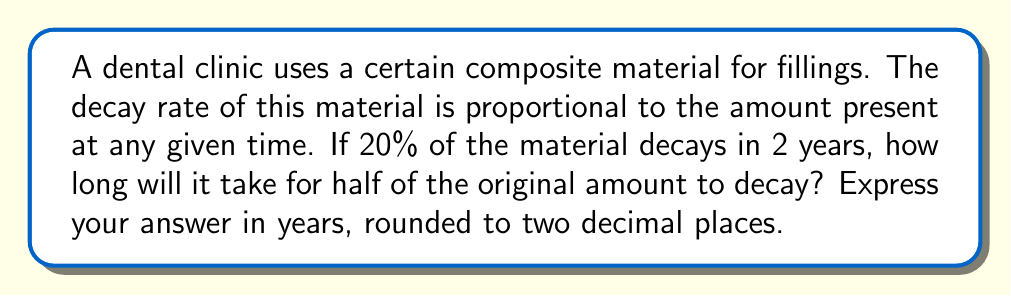Solve this math problem. Let's approach this step-by-step using differential equations:

1) Let $A(t)$ be the amount of material present at time $t$ (in years).

2) The decay rate is proportional to the amount present, so we can write:

   $$\frac{dA}{dt} = -kA$$

   where $k$ is the decay constant.

3) The solution to this differential equation is:

   $$A(t) = A_0e^{-kt}$$

   where $A_0$ is the initial amount.

4) We're told that 20% decays in 2 years. This means that after 2 years, 80% remains:

   $$\frac{A(2)}{A_0} = 0.8 = e^{-2k}$$

5) Taking the natural log of both sides:

   $$\ln(0.8) = -2k$$

6) Solving for $k$:

   $$k = -\frac{\ln(0.8)}{2} \approx 0.1115$$

7) Now, we want to find $t$ when half the original amount remains:

   $$\frac{A(t)}{A_0} = 0.5 = e^{-kt}$$

8) Taking the natural log again:

   $$\ln(0.5) = -kt$$

9) Solving for $t$:

   $$t = -\frac{\ln(0.5)}{k} = \frac{\ln(2)}{0.1115} \approx 6.22$$

Therefore, it will take approximately 6.22 years for half of the original amount to decay.
Answer: 6.22 years 